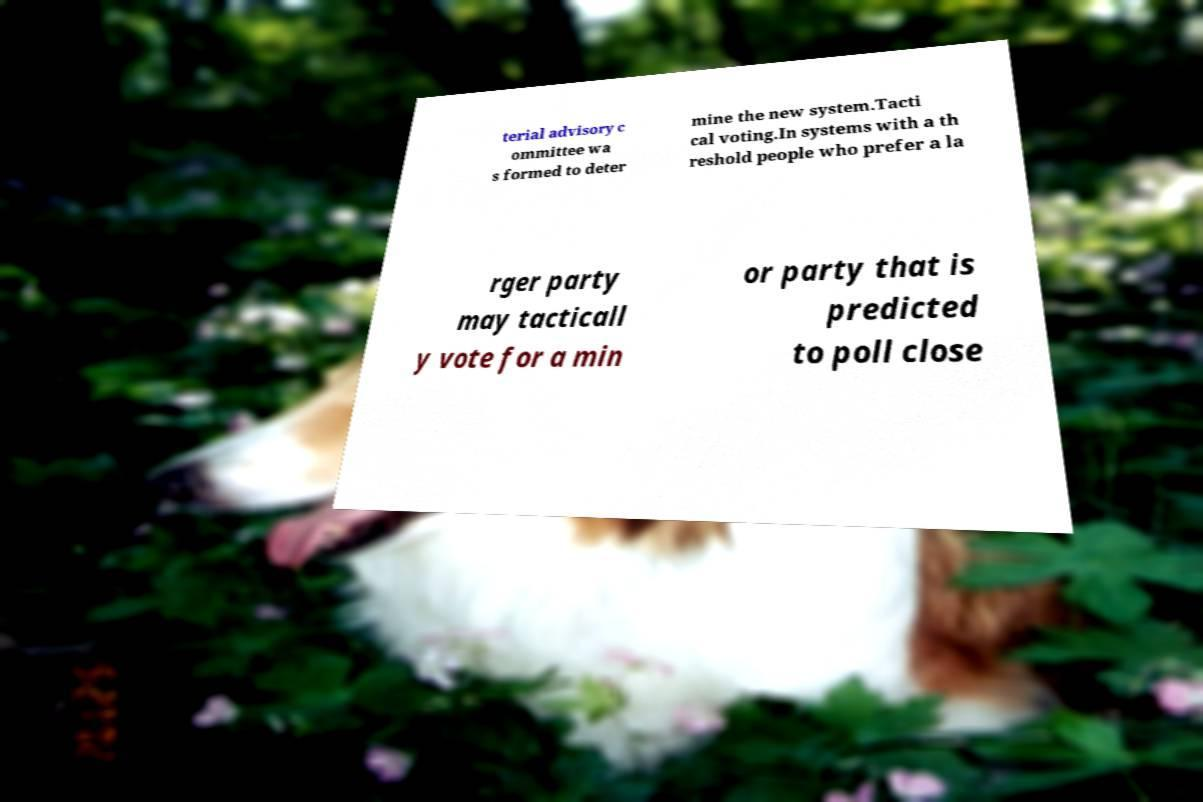Could you assist in decoding the text presented in this image and type it out clearly? terial advisory c ommittee wa s formed to deter mine the new system.Tacti cal voting.In systems with a th reshold people who prefer a la rger party may tacticall y vote for a min or party that is predicted to poll close 